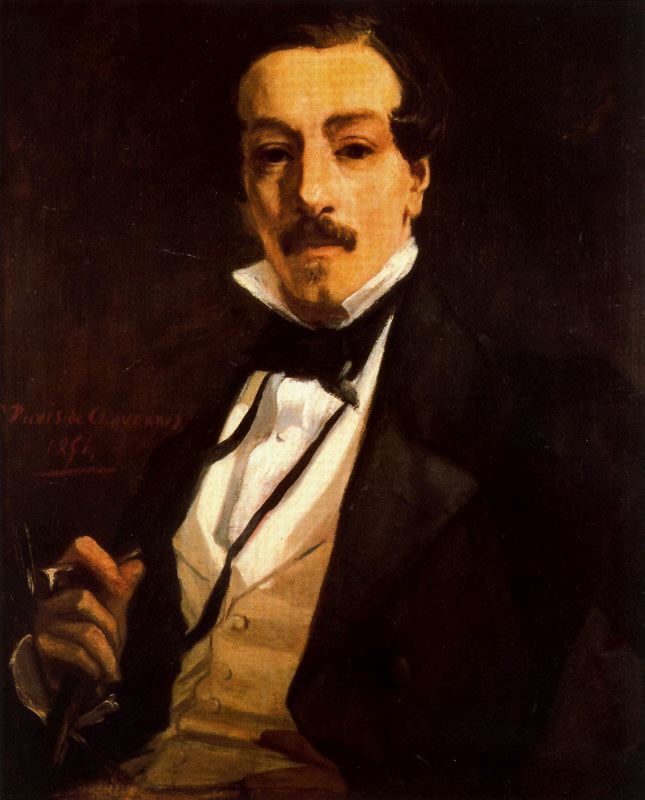What can you tell me about the artistic style used in this painting? This painting is executed in the impressionist style, characterized by its focus on light and color to evoke mood and atmosphere. Rather than detailing every element with precision, the artist uses broad, textured brushstrokes to create a sense of depth and realism that is more about the emotional and visual impact than technical accuracy. The use of high contrast between dark and light elements, along with the impression of movement in the brushwork, exemplifies the impressionist approach. The subject's expression and pose give the viewer a glimpse into a moment rather than a static study, which is a hallmark of impressionist portraits. Can you expand on how this impressionist style contributes to the overall feel of the portrait? The impressionist style significantly enhances the emotional depth and immediacy of the portrait. The broad strokes and subtle blending common in impressionism allow for a softer, more dynamic presentation of the subject. The play of light and shadow creates a lifelike quality, making the man's gaze and posture more striking and expressive. The background's lack of detail ensures that the focus is solely on the subject, emphasizing his attire, expression, and the pen he holds, thus inviting viewers to ponder his thoughts and emotions. The overall effect is one of intimacy and immediacy, making the viewer feel as though they are glimpsing a fleeting, yet profound, moment in the man's life. 